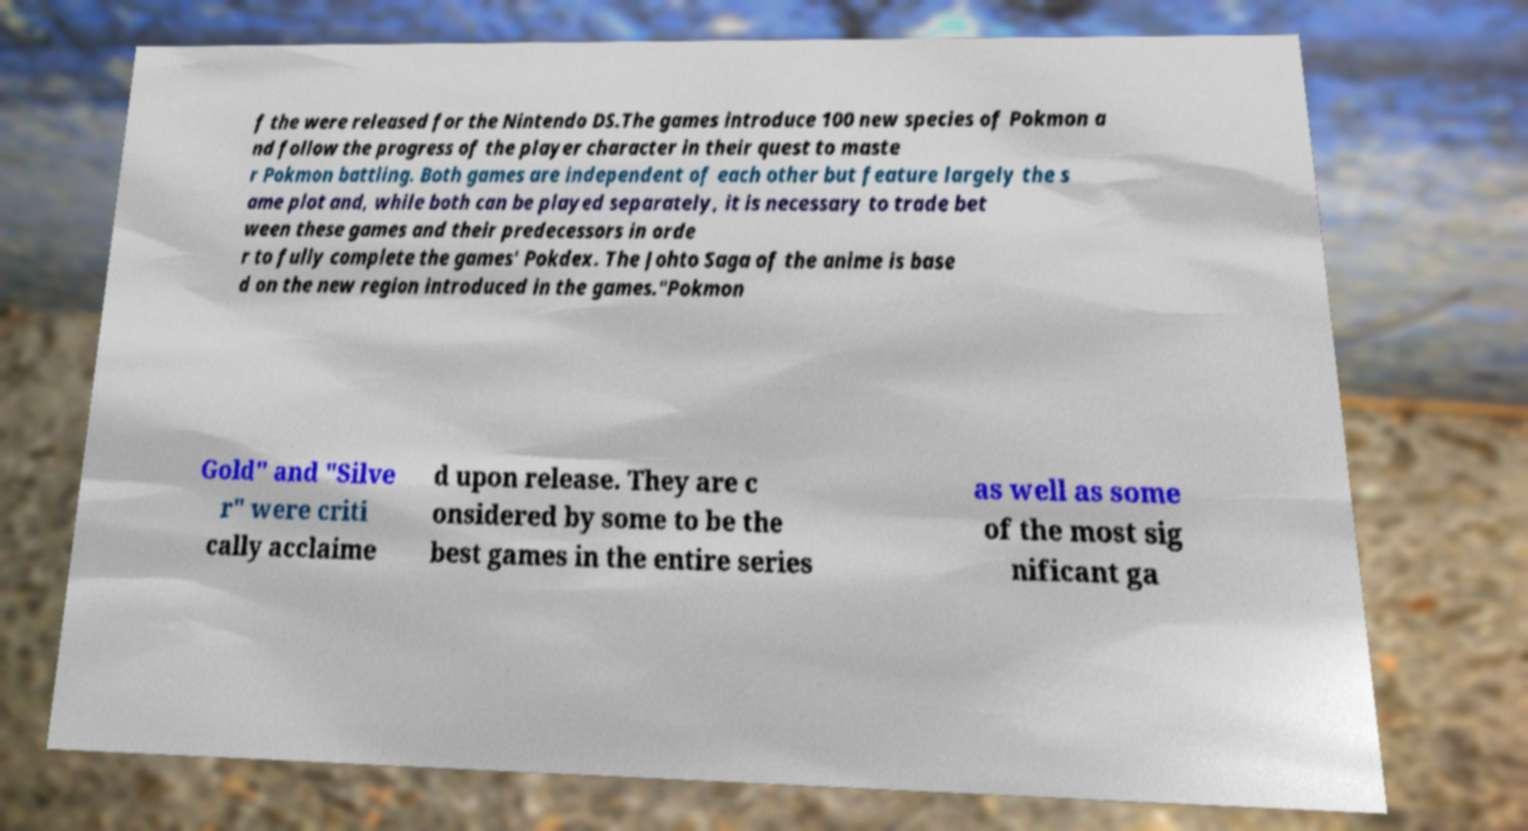There's text embedded in this image that I need extracted. Can you transcribe it verbatim? f the were released for the Nintendo DS.The games introduce 100 new species of Pokmon a nd follow the progress of the player character in their quest to maste r Pokmon battling. Both games are independent of each other but feature largely the s ame plot and, while both can be played separately, it is necessary to trade bet ween these games and their predecessors in orde r to fully complete the games' Pokdex. The Johto Saga of the anime is base d on the new region introduced in the games."Pokmon Gold" and "Silve r" were criti cally acclaime d upon release. They are c onsidered by some to be the best games in the entire series as well as some of the most sig nificant ga 